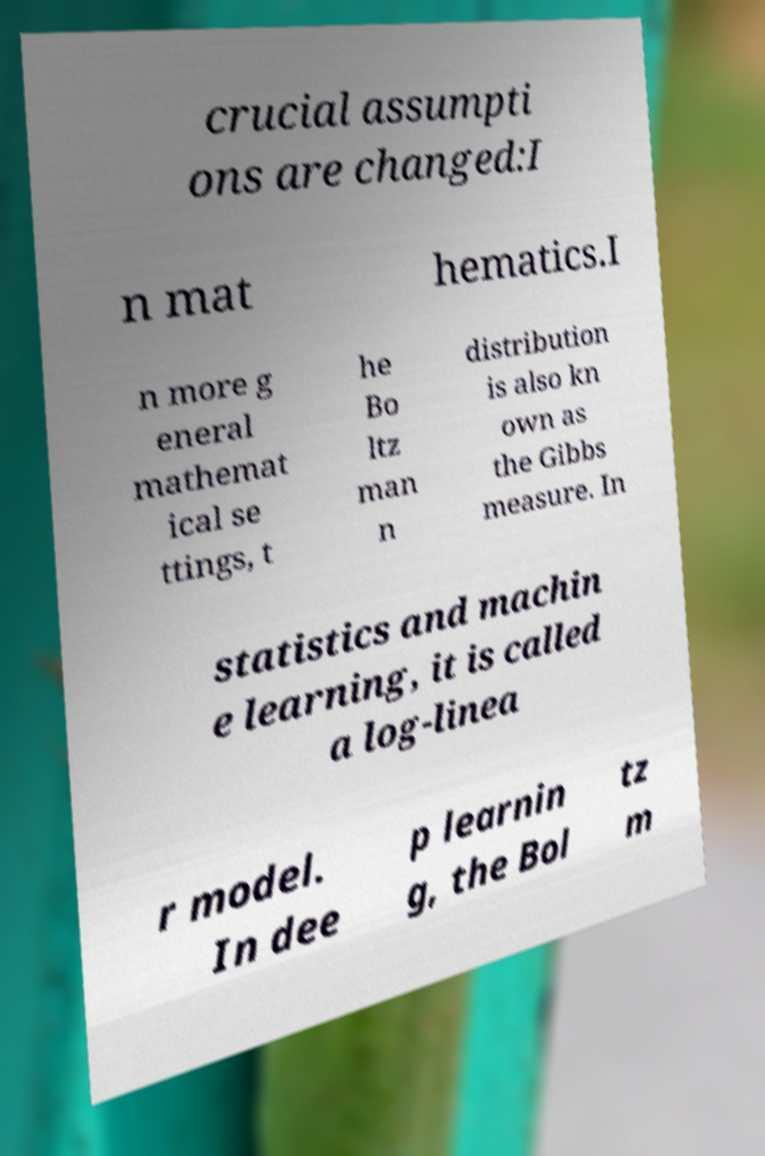Could you assist in decoding the text presented in this image and type it out clearly? crucial assumpti ons are changed:I n mat hematics.I n more g eneral mathemat ical se ttings, t he Bo ltz man n distribution is also kn own as the Gibbs measure. In statistics and machin e learning, it is called a log-linea r model. In dee p learnin g, the Bol tz m 